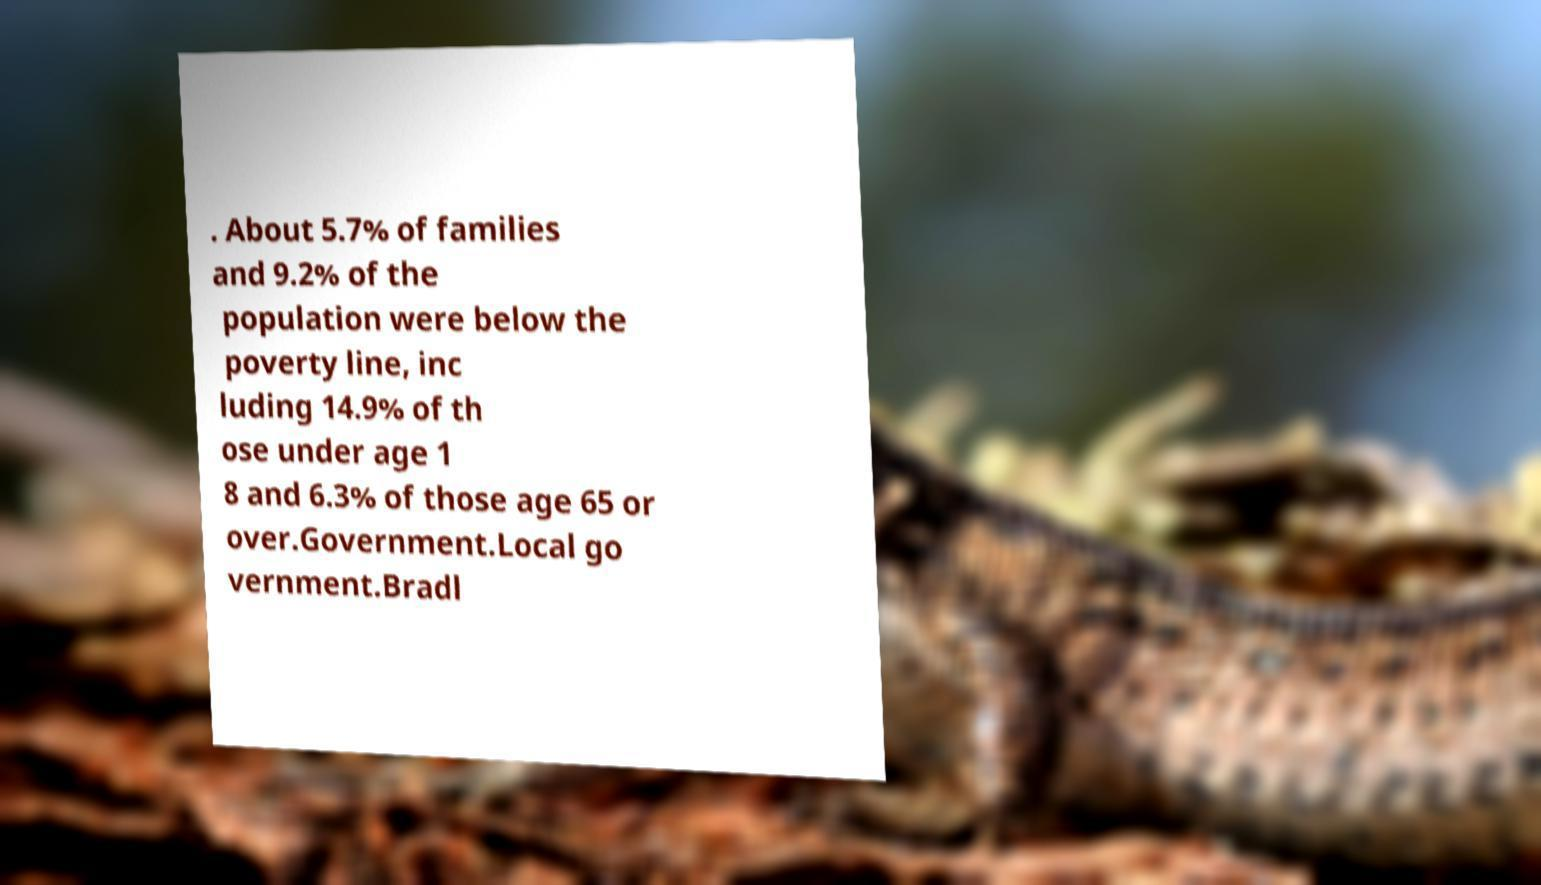I need the written content from this picture converted into text. Can you do that? . About 5.7% of families and 9.2% of the population were below the poverty line, inc luding 14.9% of th ose under age 1 8 and 6.3% of those age 65 or over.Government.Local go vernment.Bradl 